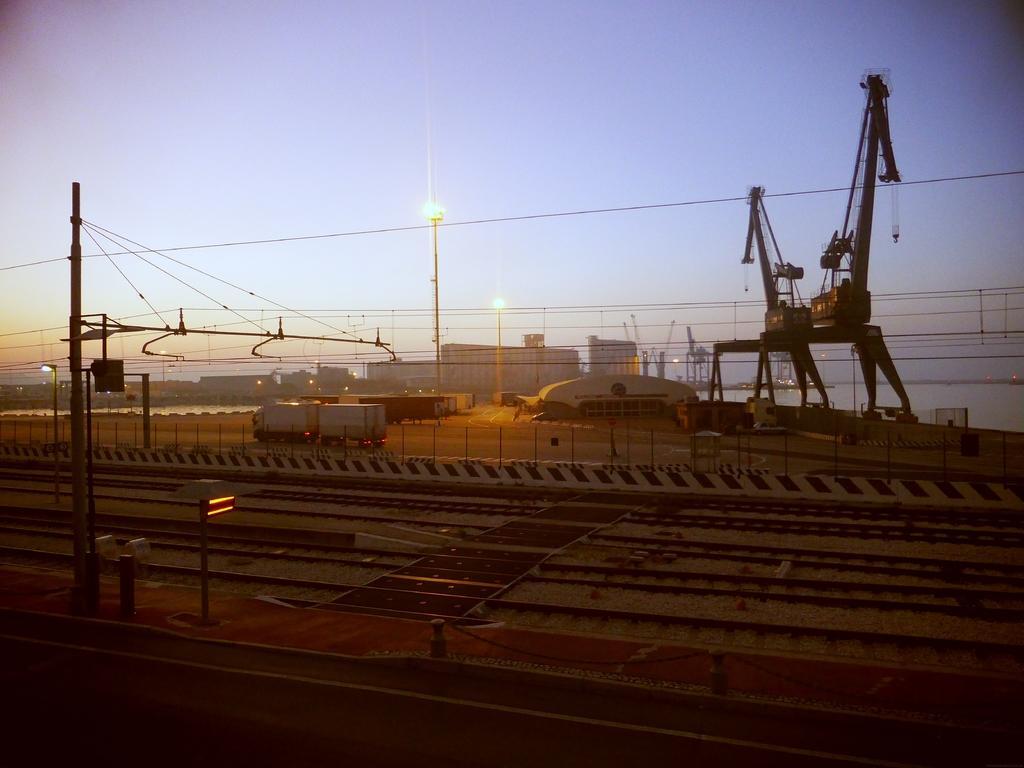Describe this image in one or two sentences. In this picture I can see the trucks, cars, trolleys, building, poles, electric wires, crane, street lights and other objects. At the bottom I can see the railway tracks and platform. At the top I can see the sky. 